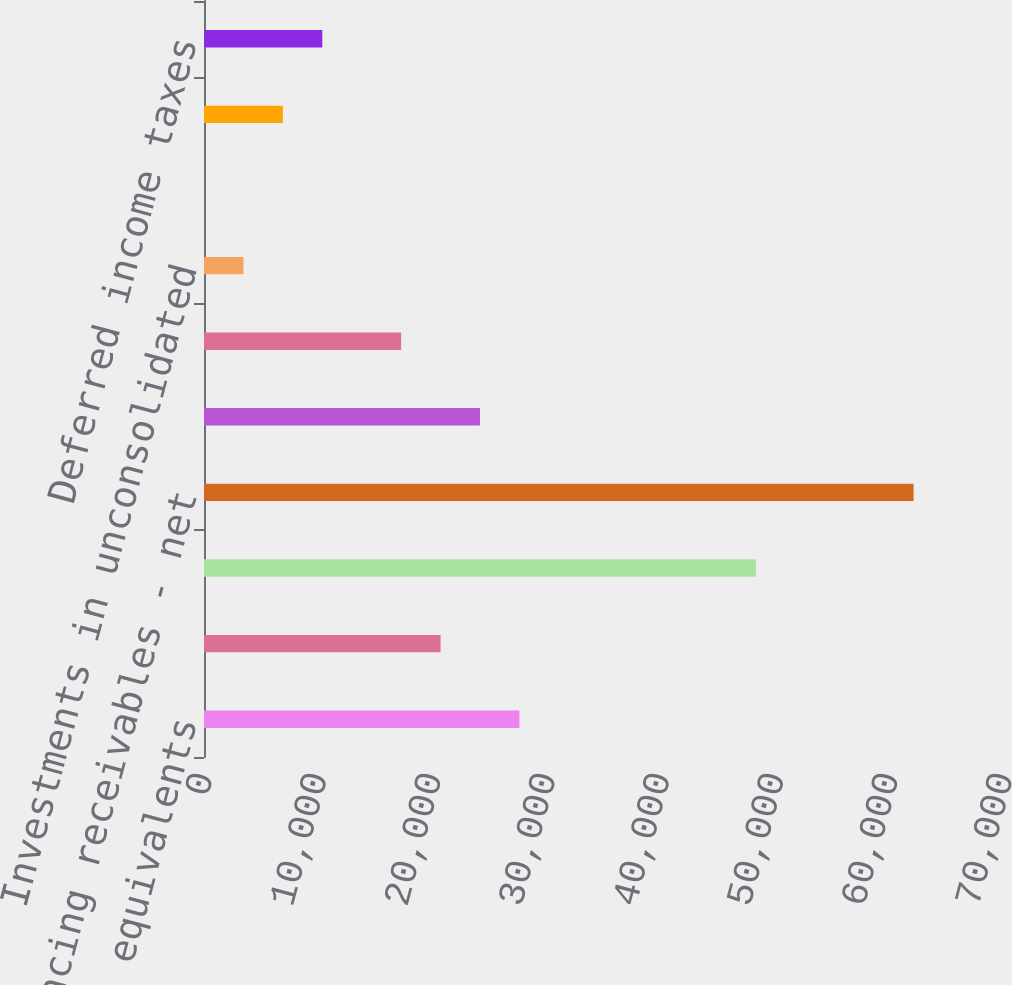Convert chart. <chart><loc_0><loc_0><loc_500><loc_500><bar_chart><fcel>Cash and cash equivalents<fcel>Marketable securities<fcel>Trade accounts and notes<fcel>Financing receivables - net<fcel>Other receivables<fcel>Property and equipment - net<fcel>Investments in unconsolidated<fcel>Other intangible assets - net<fcel>Retirement benefits<fcel>Deferred income taxes<nl><fcel>27597.2<fcel>20698.9<fcel>48292.1<fcel>62088.7<fcel>24148<fcel>17249.8<fcel>3453.15<fcel>4<fcel>6902.3<fcel>10351.5<nl></chart> 